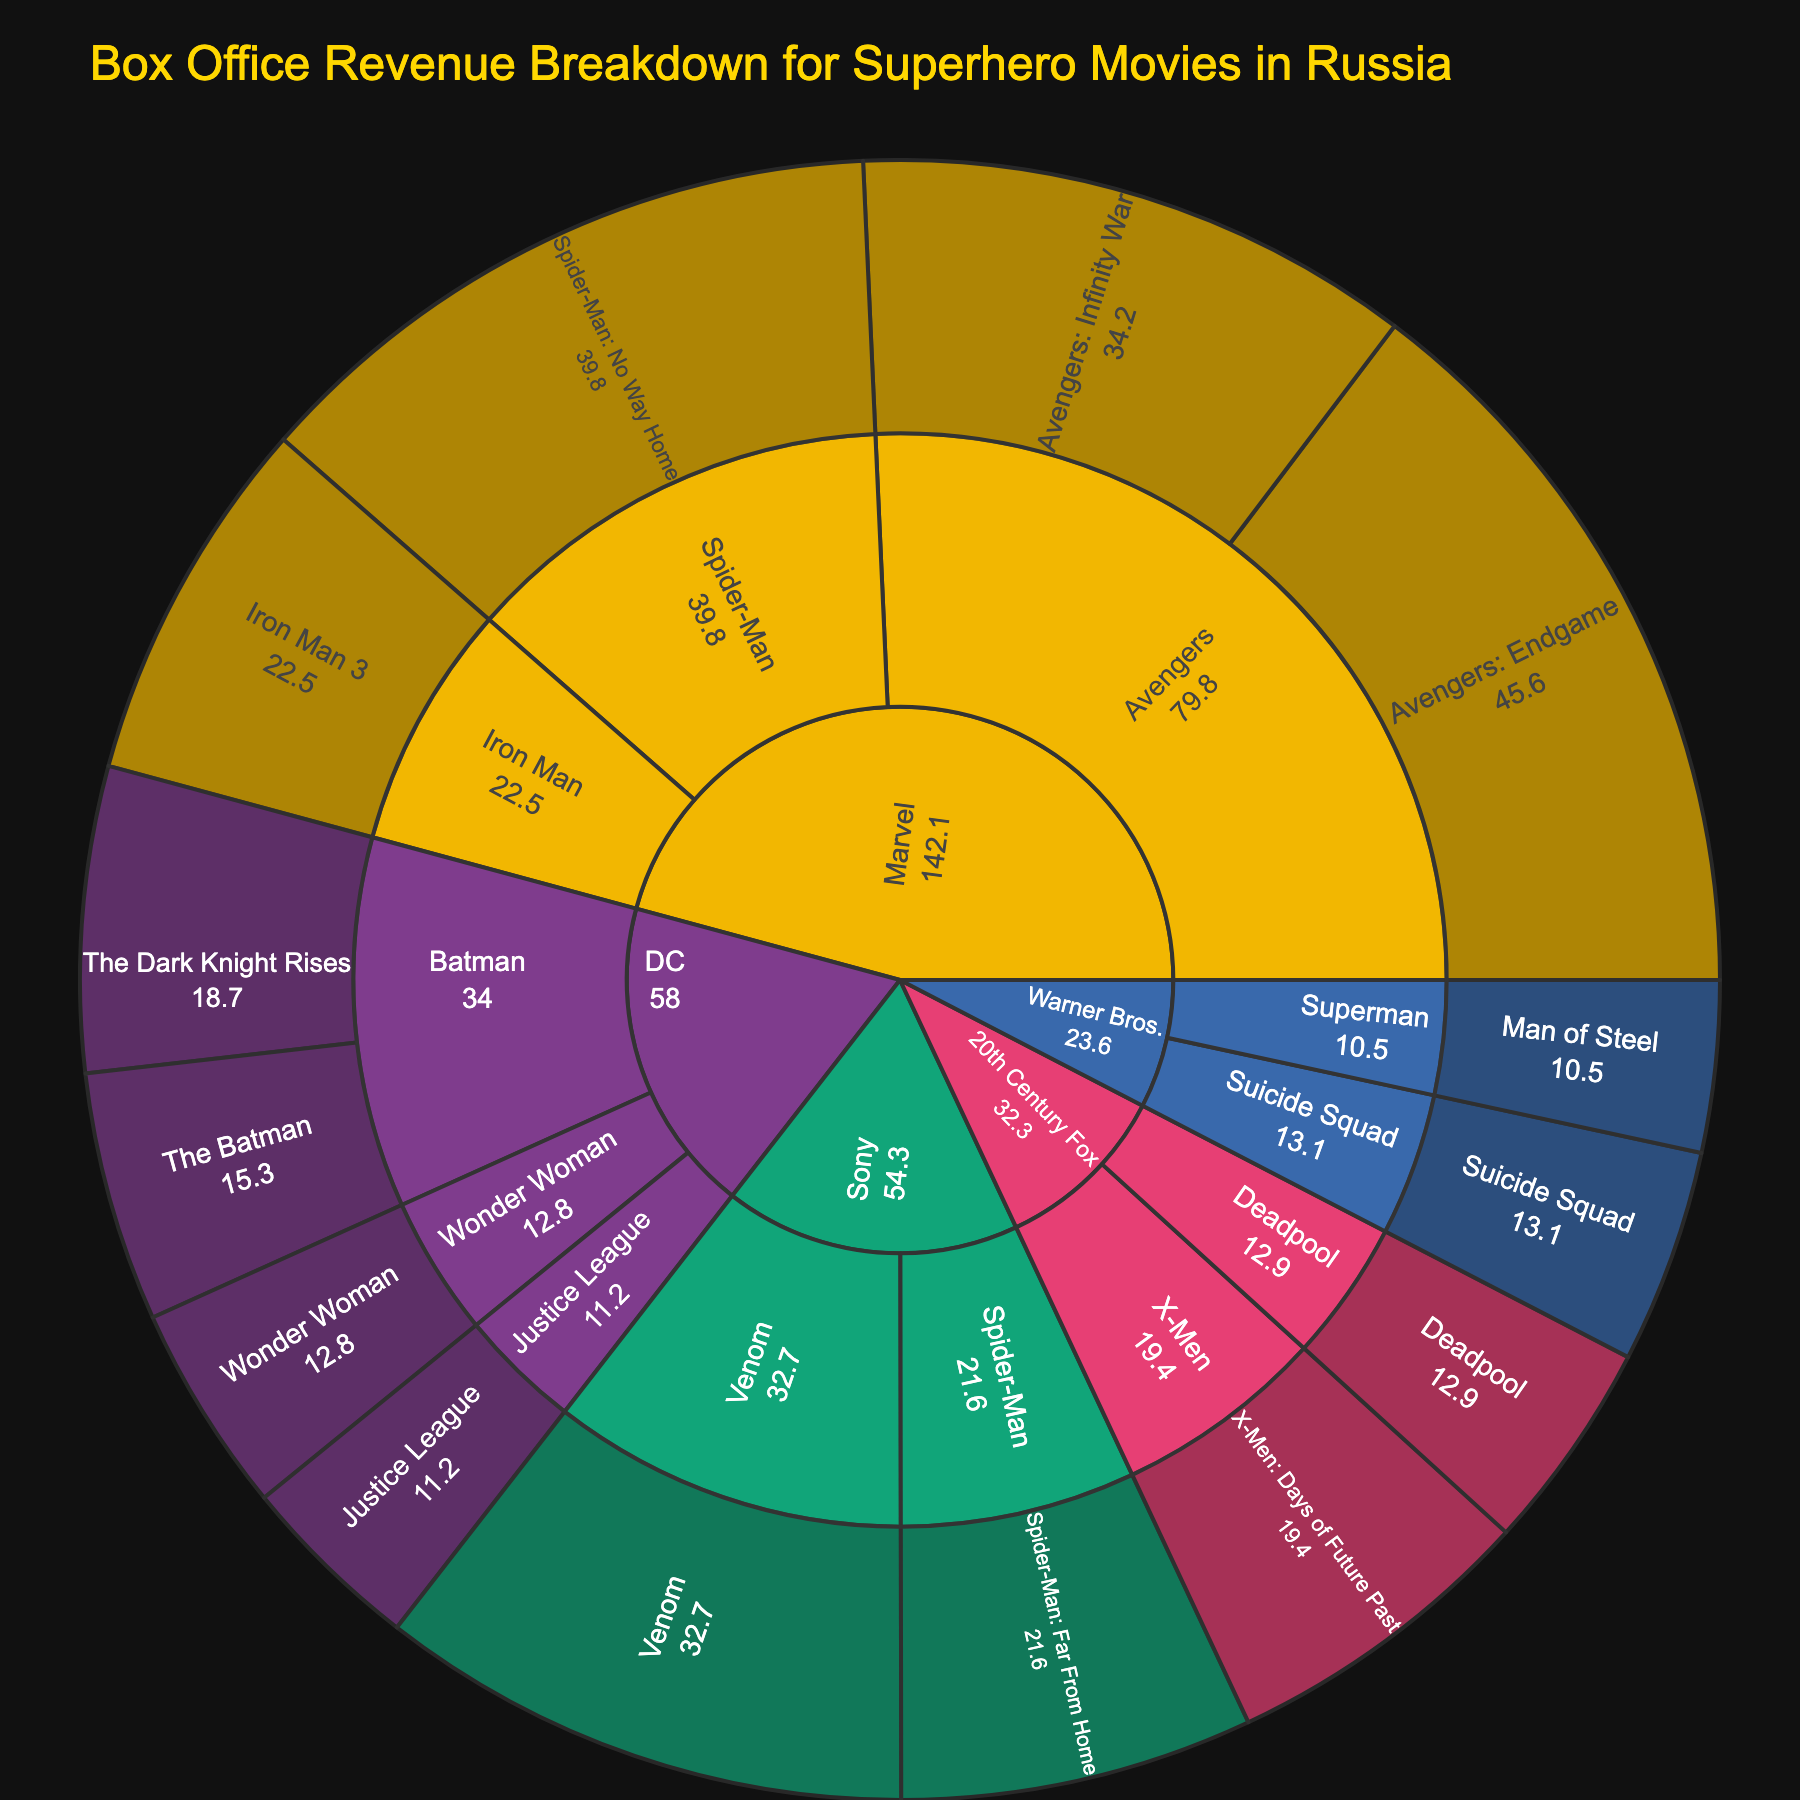What is the title of the figure? The title is usually displayed prominently at the top of the figure.
Answer: Box Office Revenue Breakdown for Superhero Movies in Russia Which studio has the highest total box office revenue in Russia? To find out the studio with the highest total revenue, sum the revenues of all movies under each studio and compare. Marvel leads with movies like Avengers: Endgame ($45.6M), Avengers: Infinity War ($34.2M), etc.
Answer: Marvel What is the total revenue generated by the Batman franchise? Sum the revenue of movies under the Batman franchise: The Batman ($15.3M) and The Dark Knight Rises ($18.7M).
Answer: $34M Which individual movie has the highest box office revenue? Look for the movie with the highest individual revenue value on the plot. In this case, Avengers: Endgame has the highest at $45.6M.
Answer: Avengers: Endgame Compare the total revenue generated by Marvel's Spider-Man franchise to Sony's Spider-Man franchise. Which franchise earned more? Sum the revenues under Marvel’s Spider-Man (Spider-Man: No Way Home) and Sony’s Spider-Man (Spider-Man: Far From Home) and compare. Marvel: $39.8M, Sony: $21.6M.
Answer: Marvel How does the revenue of The Batman compare to Iron Man 3? Compare the revenue of The Batman ($15.3M) and Iron Man 3 ($22.5M).
Answer: Iron Man 3 has higher revenue What percentage of the total DC revenue is generated by the Justice League movie? Sum the total revenue of all DC movies and calculate the percentage contribution of Justice League ($11.2M). Total DC revenue: 15.3 + 18.7 + 11.2 + 12.8 = $58M. Percentage: (11.2 / 58) * 100 ≈ 19.3%.
Answer: 19.3% Which studio has the smallest contribution in terms of box office revenue? Compare the total revenues of all studios and identify the smallest one. Warner Bros. has only two movies: Man of Steel ($10.5M) and Suicide Squad ($13.1M). Total: $23.6M.
Answer: Warner Bros If you sum all the revenues from Marvel studios, what do you get? Sum the revenues of all Marvel movies: 45.6 + 34.2 + 39.8 + 22.5 = $142.1M.
Answer: $142.1M What's the total revenue for superhero movies that are not from Marvel? Sum the revenues of all movies from studios other than Marvel: DC, Sony, 20th Century Fox, Warner Bros. ($58M + $54.3M + $32.3M + $23.6M). Total: $168.2M.
Answer: $168.2M 